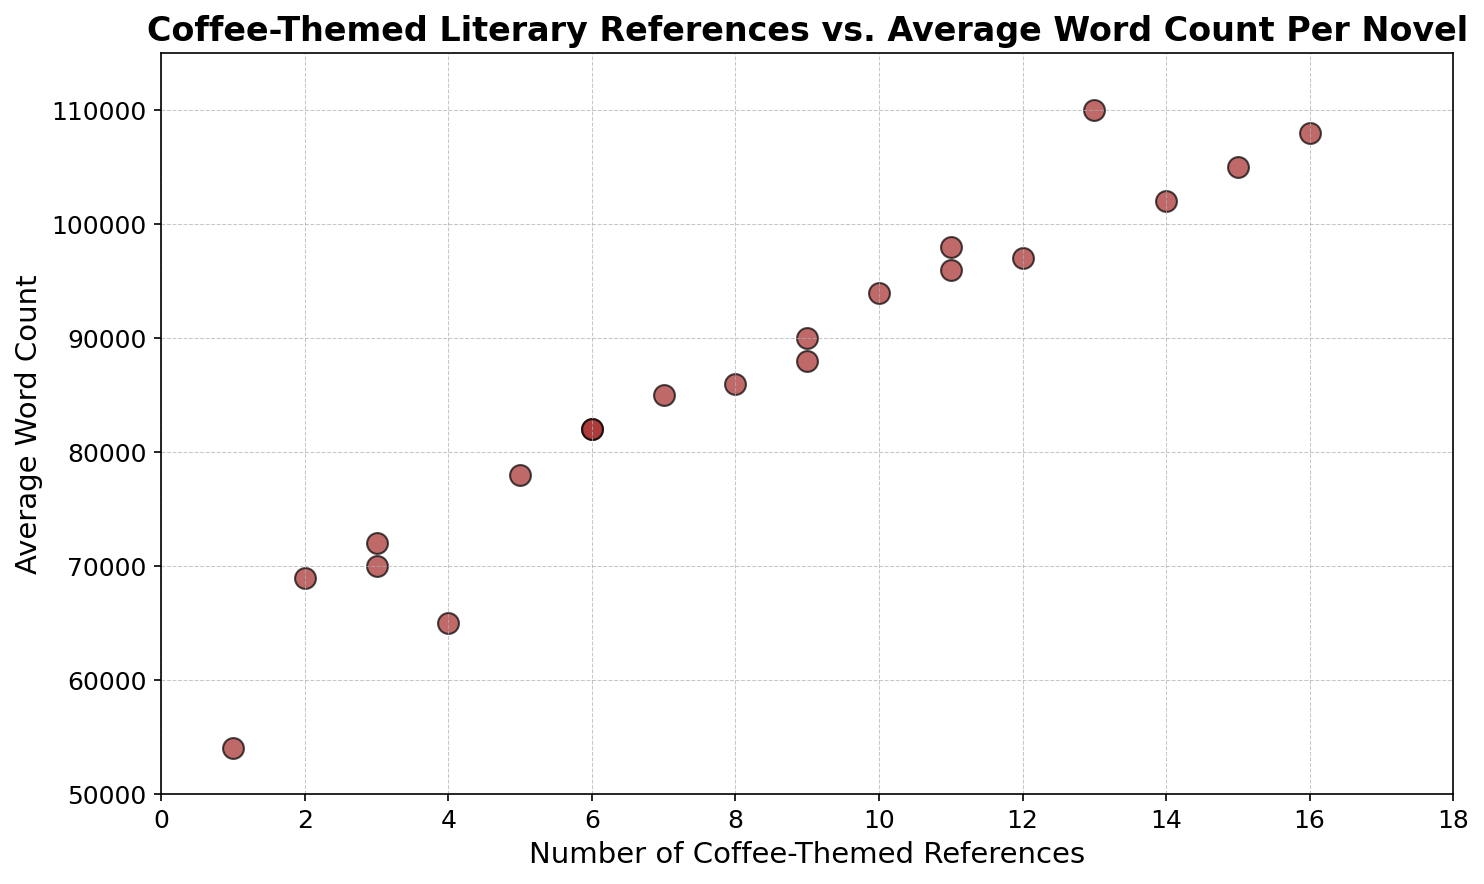What's the general trend between the number of coffee-themed references and the average word count? The scatter plot shows that generally, as the number of coffee-themed references increases, the average word count also tends to increase. This can be observed by noting that higher numbers of references are usually associated with higher word counts.
Answer: Increasing What is the approximate average word count of novels with the lowest number of coffee-themed references? There is a data point with the lowest number of coffee-themed references, which is 1. The average word count for this data point is approximately 54,000 words.
Answer: 54,000 Which novel has the highest average word count, and how many coffee-themed references does it contain? The scatter plot indicates the novel with the highest average word count has around 110,000 words. This novel contains 13 coffee-themed references.
Answer: 13 references Are there more novels with fewer than 10 coffee-themed references or more than 10 references? By counting the data points on the scatter plot, there are 13 novels with fewer than 10 coffee-themed references and 7 novels with more than 10 references. Thus, there are more novels with fewer than 10 coffee-themed references.
Answer: Fewer than 10 How does the average word count compare for novels with 1 coffee-themed reference versus those with 16? The average word count for the novel with 1 coffee-themed reference is about 54,000 words, whereas for the novel with 16 references, it is approximately 108,000 words. This indicates that the novel with 16 references has a significantly higher average word count.
Answer: 108,000 vs. 54,000 What would be the trend if we take the difference in average word counts between novels with 15 and 2 coffee-themed references? The novel with 15 references has an average word count of about 105,000, and the novel with 2 references has about 69,000. The difference is 105,000 - 69,000 = 36,000.
Answer: 36,000 Is there any novel with exactly 10 coffee-themed references? If so, what is its average word count? Yes, there is a novel with exactly 10 coffee-themed references. Its average word count is approximately 94,000 words.
Answer: 94,000 How many novels have an average word count above 100,000 and how many coffee-themed references do they each have? From the scatter plot, there are 4 novels with an average word count above 100,000. These novels have 13, 14, 15, and 16 coffee-themed references respectively.
Answer: 4 novels: 13, 14, 15, 16 references What color and size are used for the scatter plot markers, and what do these visual choices typically signify? The scatter plot markers are brown with black edges and are relatively large. The color brown likely signifies the coffee theme, and the larger size of the markers indicates that they denote individual novels rather than aggregated data.
Answer: Brown, large 